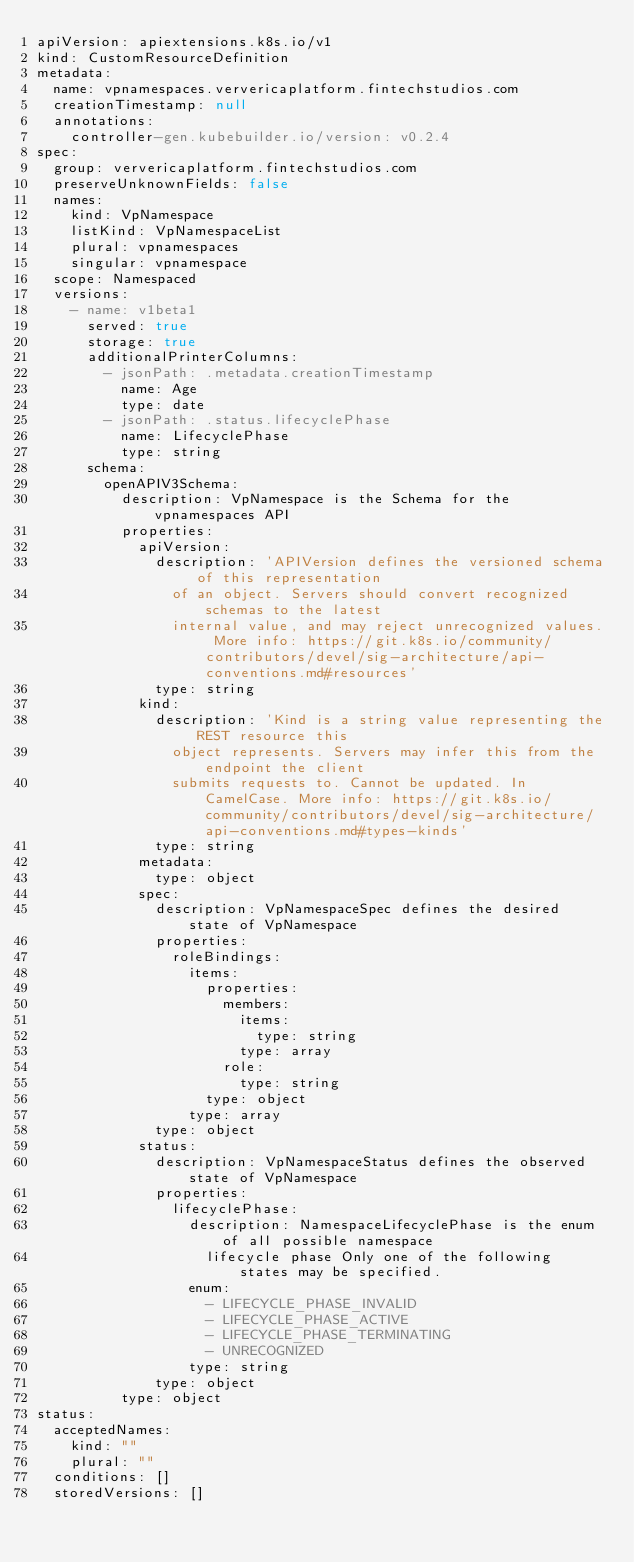Convert code to text. <code><loc_0><loc_0><loc_500><loc_500><_YAML_>apiVersion: apiextensions.k8s.io/v1
kind: CustomResourceDefinition
metadata:
  name: vpnamespaces.ververicaplatform.fintechstudios.com
  creationTimestamp: null
  annotations:
    controller-gen.kubebuilder.io/version: v0.2.4
spec:
  group: ververicaplatform.fintechstudios.com
  preserveUnknownFields: false
  names:
    kind: VpNamespace
    listKind: VpNamespaceList
    plural: vpnamespaces
    singular: vpnamespace
  scope: Namespaced
  versions:
    - name: v1beta1
      served: true
      storage: true
      additionalPrinterColumns:
        - jsonPath: .metadata.creationTimestamp
          name: Age
          type: date
        - jsonPath: .status.lifecyclePhase
          name: LifecyclePhase
          type: string
      schema:
        openAPIV3Schema:
          description: VpNamespace is the Schema for the vpnamespaces API
          properties:
            apiVersion:
              description: 'APIVersion defines the versioned schema of this representation
                of an object. Servers should convert recognized schemas to the latest
                internal value, and may reject unrecognized values. More info: https://git.k8s.io/community/contributors/devel/sig-architecture/api-conventions.md#resources'
              type: string
            kind:
              description: 'Kind is a string value representing the REST resource this
                object represents. Servers may infer this from the endpoint the client
                submits requests to. Cannot be updated. In CamelCase. More info: https://git.k8s.io/community/contributors/devel/sig-architecture/api-conventions.md#types-kinds'
              type: string
            metadata:
              type: object
            spec:
              description: VpNamespaceSpec defines the desired state of VpNamespace
              properties:
                roleBindings:
                  items:
                    properties:
                      members:
                        items:
                          type: string
                        type: array
                      role:
                        type: string
                    type: object
                  type: array
              type: object
            status:
              description: VpNamespaceStatus defines the observed state of VpNamespace
              properties:
                lifecyclePhase:
                  description: NamespaceLifecyclePhase is the enum of all possible namespace
                    lifecycle phase Only one of the following states may be specified.
                  enum:
                    - LIFECYCLE_PHASE_INVALID
                    - LIFECYCLE_PHASE_ACTIVE
                    - LIFECYCLE_PHASE_TERMINATING
                    - UNRECOGNIZED
                  type: string
              type: object
          type: object
status:
  acceptedNames:
    kind: ""
    plural: ""
  conditions: []
  storedVersions: []</code> 